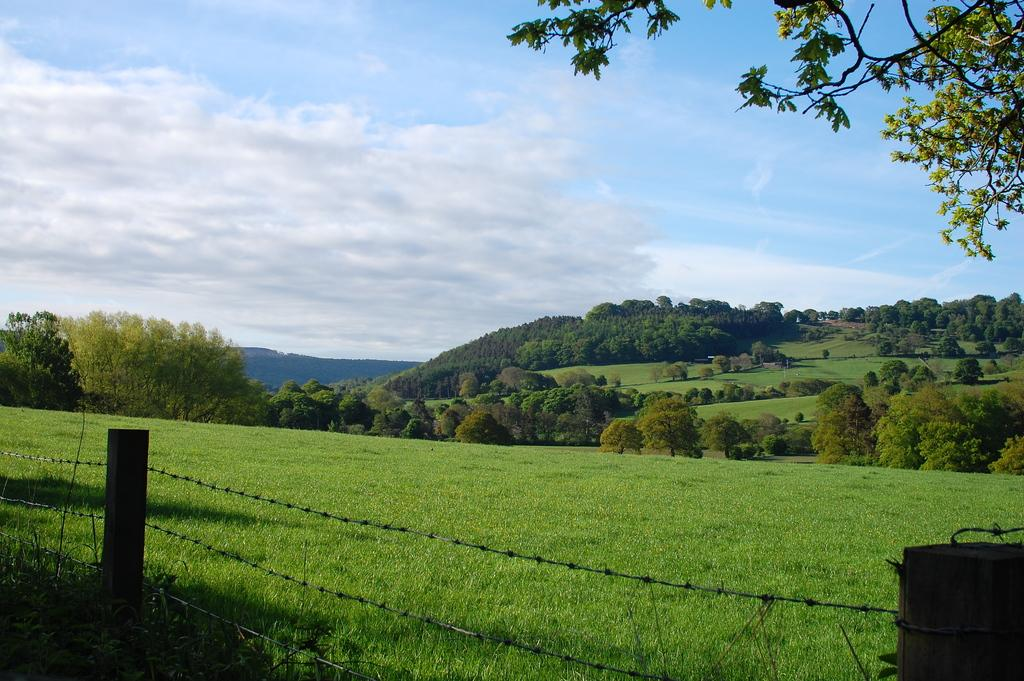What type of structure can be seen in the image? There is fencing in the image. What type of vegetation is present in the image? There is green grass and trees in the image. What can be seen in the background of the image? The sky is visible in the background of the image. What is the condition of the sky in the image? The sky appears to be clear in the image. What type of drink is the mother holding in the image? There is no mother or drink present in the image. 